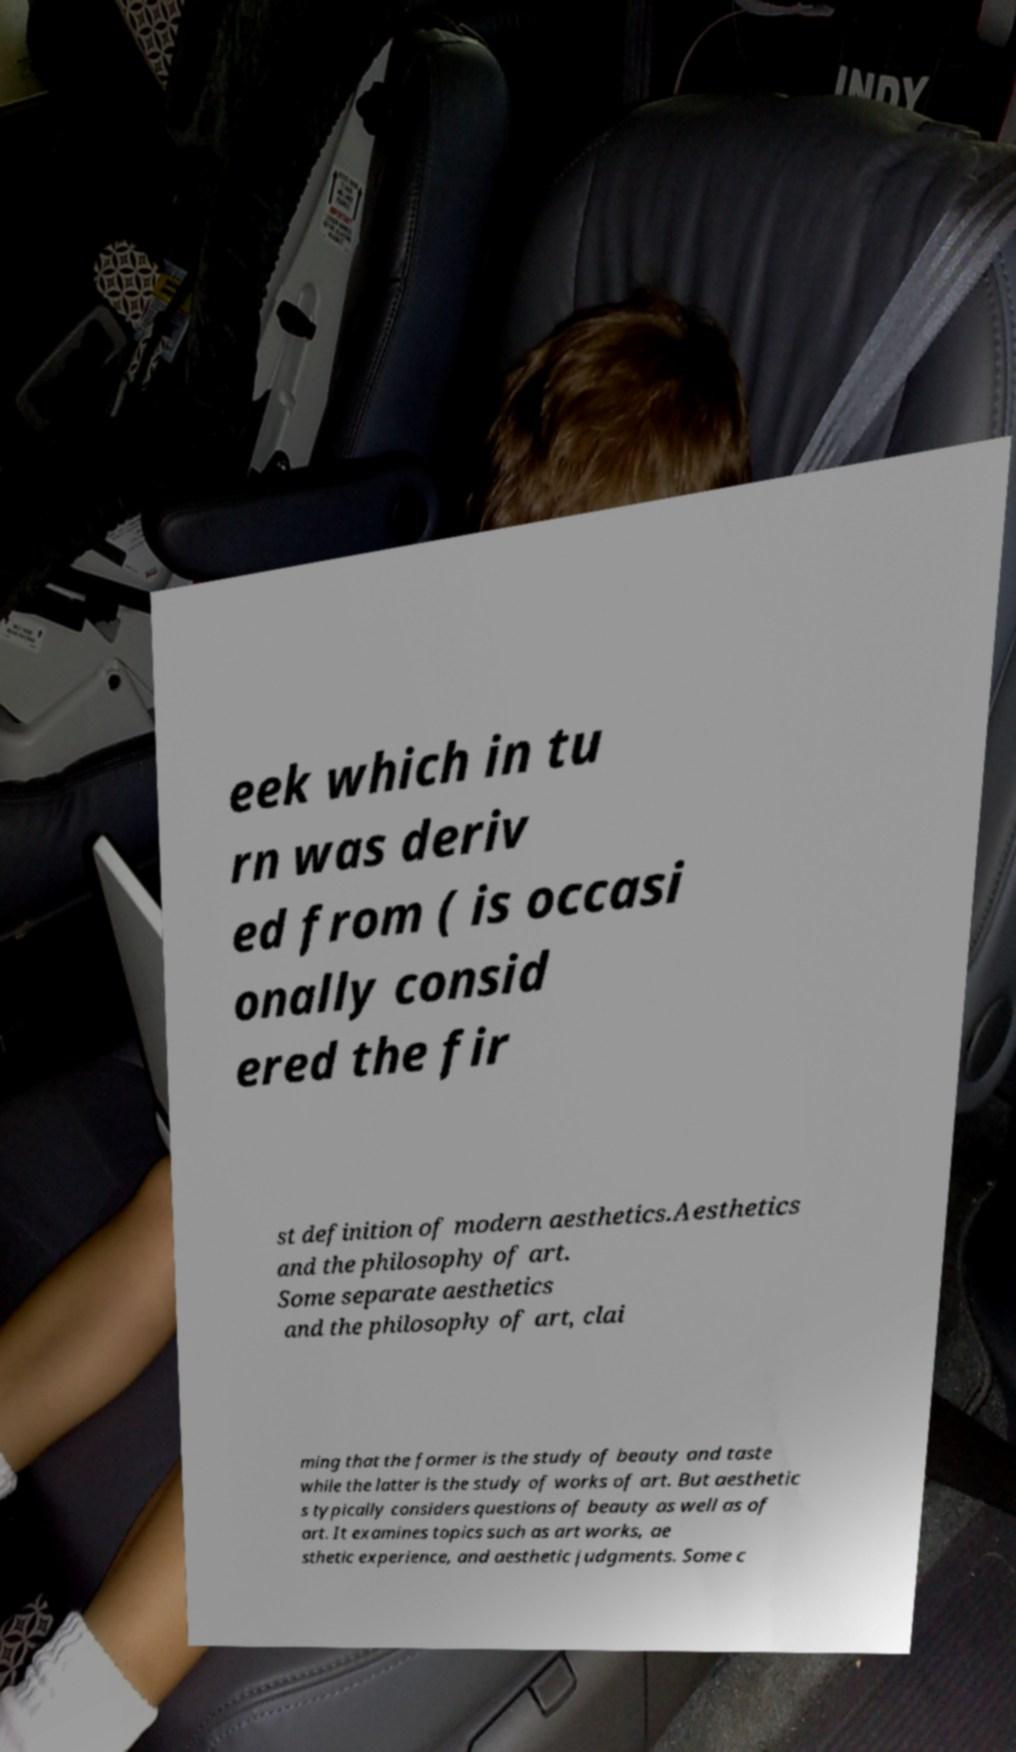There's text embedded in this image that I need extracted. Can you transcribe it verbatim? eek which in tu rn was deriv ed from ( is occasi onally consid ered the fir st definition of modern aesthetics.Aesthetics and the philosophy of art. Some separate aesthetics and the philosophy of art, clai ming that the former is the study of beauty and taste while the latter is the study of works of art. But aesthetic s typically considers questions of beauty as well as of art. It examines topics such as art works, ae sthetic experience, and aesthetic judgments. Some c 